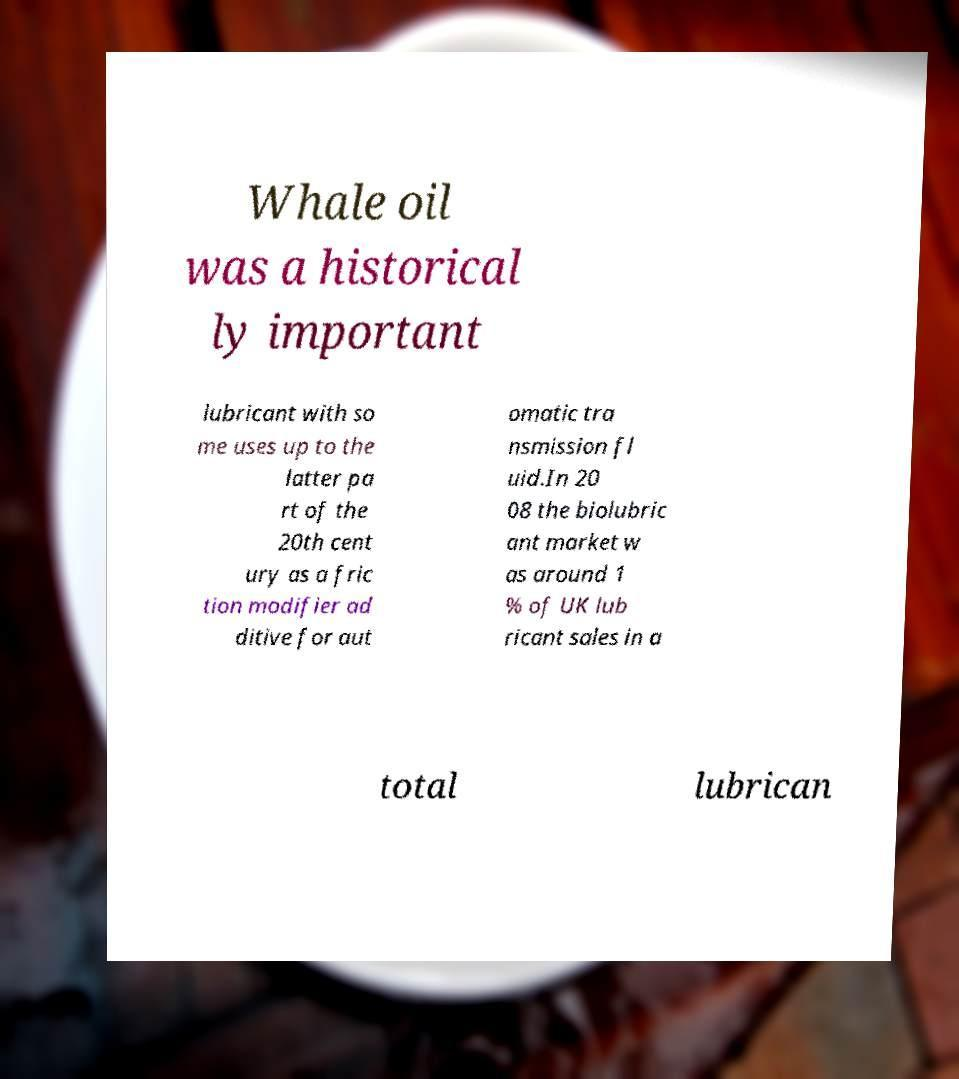Can you read and provide the text displayed in the image?This photo seems to have some interesting text. Can you extract and type it out for me? Whale oil was a historical ly important lubricant with so me uses up to the latter pa rt of the 20th cent ury as a fric tion modifier ad ditive for aut omatic tra nsmission fl uid.In 20 08 the biolubric ant market w as around 1 % of UK lub ricant sales in a total lubrican 